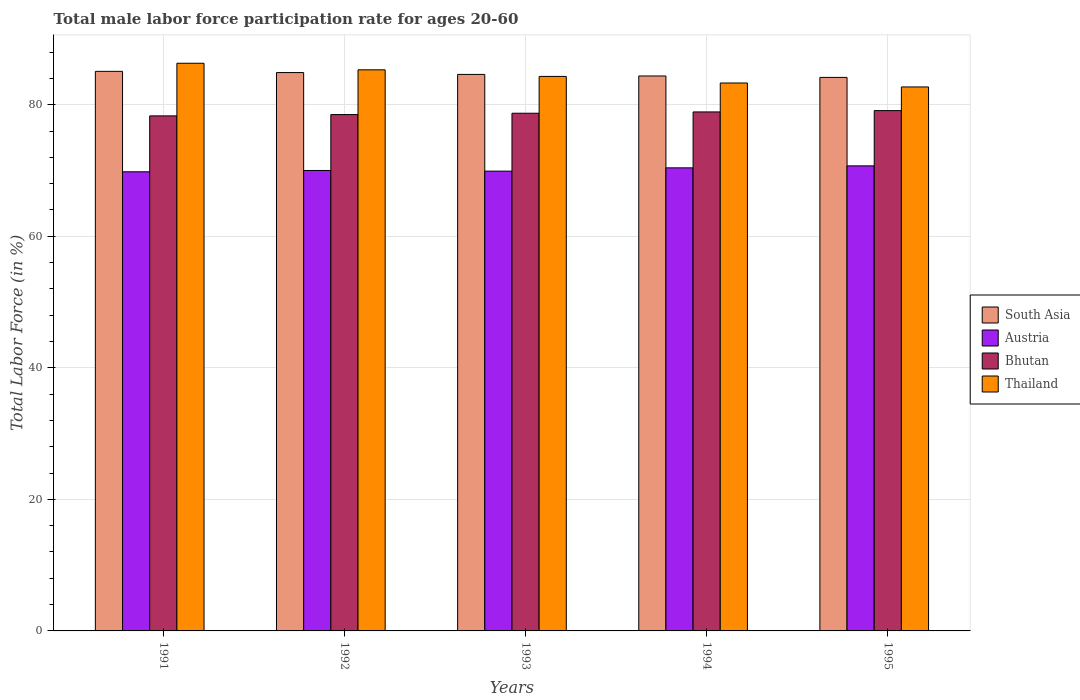How many different coloured bars are there?
Offer a terse response. 4. Are the number of bars per tick equal to the number of legend labels?
Provide a short and direct response. Yes. What is the label of the 4th group of bars from the left?
Keep it short and to the point. 1994. What is the male labor force participation rate in Thailand in 1992?
Provide a succinct answer. 85.3. Across all years, what is the maximum male labor force participation rate in Bhutan?
Offer a very short reply. 79.1. Across all years, what is the minimum male labor force participation rate in Austria?
Provide a succinct answer. 69.8. In which year was the male labor force participation rate in Thailand maximum?
Your answer should be very brief. 1991. In which year was the male labor force participation rate in South Asia minimum?
Your answer should be very brief. 1995. What is the total male labor force participation rate in South Asia in the graph?
Offer a terse response. 423.08. What is the difference between the male labor force participation rate in Bhutan in 1993 and that in 1994?
Your answer should be very brief. -0.2. What is the difference between the male labor force participation rate in Austria in 1991 and the male labor force participation rate in Thailand in 1994?
Your answer should be very brief. -13.5. What is the average male labor force participation rate in Thailand per year?
Your response must be concise. 84.38. In the year 1993, what is the difference between the male labor force participation rate in Thailand and male labor force participation rate in Bhutan?
Provide a succinct answer. 5.6. What is the ratio of the male labor force participation rate in South Asia in 1992 to that in 1995?
Provide a short and direct response. 1.01. Is the male labor force participation rate in South Asia in 1991 less than that in 1992?
Provide a succinct answer. No. Is the difference between the male labor force participation rate in Thailand in 1992 and 1993 greater than the difference between the male labor force participation rate in Bhutan in 1992 and 1993?
Your answer should be very brief. Yes. What is the difference between the highest and the second highest male labor force participation rate in South Asia?
Offer a very short reply. 0.19. What is the difference between the highest and the lowest male labor force participation rate in Thailand?
Offer a terse response. 3.6. In how many years, is the male labor force participation rate in Bhutan greater than the average male labor force participation rate in Bhutan taken over all years?
Ensure brevity in your answer.  2. What does the 4th bar from the left in 1991 represents?
Your response must be concise. Thailand. What does the 4th bar from the right in 1995 represents?
Give a very brief answer. South Asia. Is it the case that in every year, the sum of the male labor force participation rate in Bhutan and male labor force participation rate in Austria is greater than the male labor force participation rate in Thailand?
Keep it short and to the point. Yes. How many bars are there?
Provide a short and direct response. 20. How many years are there in the graph?
Give a very brief answer. 5. What is the difference between two consecutive major ticks on the Y-axis?
Ensure brevity in your answer.  20. Are the values on the major ticks of Y-axis written in scientific E-notation?
Provide a short and direct response. No. Does the graph contain grids?
Offer a very short reply. Yes. Where does the legend appear in the graph?
Your answer should be compact. Center right. How are the legend labels stacked?
Provide a short and direct response. Vertical. What is the title of the graph?
Offer a very short reply. Total male labor force participation rate for ages 20-60. What is the label or title of the Y-axis?
Your answer should be compact. Total Labor Force (in %). What is the Total Labor Force (in %) in South Asia in 1991?
Your response must be concise. 85.07. What is the Total Labor Force (in %) in Austria in 1991?
Ensure brevity in your answer.  69.8. What is the Total Labor Force (in %) in Bhutan in 1991?
Your answer should be compact. 78.3. What is the Total Labor Force (in %) of Thailand in 1991?
Provide a short and direct response. 86.3. What is the Total Labor Force (in %) of South Asia in 1992?
Make the answer very short. 84.88. What is the Total Labor Force (in %) in Austria in 1992?
Make the answer very short. 70. What is the Total Labor Force (in %) in Bhutan in 1992?
Your answer should be very brief. 78.5. What is the Total Labor Force (in %) in Thailand in 1992?
Your answer should be very brief. 85.3. What is the Total Labor Force (in %) in South Asia in 1993?
Offer a very short reply. 84.6. What is the Total Labor Force (in %) in Austria in 1993?
Provide a short and direct response. 69.9. What is the Total Labor Force (in %) in Bhutan in 1993?
Offer a very short reply. 78.7. What is the Total Labor Force (in %) of Thailand in 1993?
Offer a very short reply. 84.3. What is the Total Labor Force (in %) in South Asia in 1994?
Offer a very short reply. 84.37. What is the Total Labor Force (in %) of Austria in 1994?
Make the answer very short. 70.4. What is the Total Labor Force (in %) of Bhutan in 1994?
Your response must be concise. 78.9. What is the Total Labor Force (in %) in Thailand in 1994?
Offer a terse response. 83.3. What is the Total Labor Force (in %) of South Asia in 1995?
Your answer should be very brief. 84.15. What is the Total Labor Force (in %) in Austria in 1995?
Make the answer very short. 70.7. What is the Total Labor Force (in %) in Bhutan in 1995?
Provide a short and direct response. 79.1. What is the Total Labor Force (in %) of Thailand in 1995?
Your answer should be very brief. 82.7. Across all years, what is the maximum Total Labor Force (in %) in South Asia?
Make the answer very short. 85.07. Across all years, what is the maximum Total Labor Force (in %) of Austria?
Offer a terse response. 70.7. Across all years, what is the maximum Total Labor Force (in %) of Bhutan?
Make the answer very short. 79.1. Across all years, what is the maximum Total Labor Force (in %) in Thailand?
Keep it short and to the point. 86.3. Across all years, what is the minimum Total Labor Force (in %) of South Asia?
Provide a succinct answer. 84.15. Across all years, what is the minimum Total Labor Force (in %) of Austria?
Ensure brevity in your answer.  69.8. Across all years, what is the minimum Total Labor Force (in %) of Bhutan?
Keep it short and to the point. 78.3. Across all years, what is the minimum Total Labor Force (in %) in Thailand?
Give a very brief answer. 82.7. What is the total Total Labor Force (in %) in South Asia in the graph?
Offer a terse response. 423.08. What is the total Total Labor Force (in %) of Austria in the graph?
Make the answer very short. 350.8. What is the total Total Labor Force (in %) of Bhutan in the graph?
Your response must be concise. 393.5. What is the total Total Labor Force (in %) in Thailand in the graph?
Provide a succinct answer. 421.9. What is the difference between the Total Labor Force (in %) in South Asia in 1991 and that in 1992?
Give a very brief answer. 0.19. What is the difference between the Total Labor Force (in %) in South Asia in 1991 and that in 1993?
Ensure brevity in your answer.  0.47. What is the difference between the Total Labor Force (in %) of Austria in 1991 and that in 1993?
Provide a short and direct response. -0.1. What is the difference between the Total Labor Force (in %) in Bhutan in 1991 and that in 1993?
Provide a short and direct response. -0.4. What is the difference between the Total Labor Force (in %) of Thailand in 1991 and that in 1993?
Make the answer very short. 2. What is the difference between the Total Labor Force (in %) in South Asia in 1991 and that in 1994?
Your answer should be compact. 0.7. What is the difference between the Total Labor Force (in %) in Austria in 1991 and that in 1994?
Keep it short and to the point. -0.6. What is the difference between the Total Labor Force (in %) in Bhutan in 1991 and that in 1994?
Give a very brief answer. -0.6. What is the difference between the Total Labor Force (in %) of Thailand in 1991 and that in 1994?
Your answer should be compact. 3. What is the difference between the Total Labor Force (in %) of South Asia in 1991 and that in 1995?
Your answer should be very brief. 0.92. What is the difference between the Total Labor Force (in %) in Austria in 1991 and that in 1995?
Ensure brevity in your answer.  -0.9. What is the difference between the Total Labor Force (in %) of Thailand in 1991 and that in 1995?
Ensure brevity in your answer.  3.6. What is the difference between the Total Labor Force (in %) of South Asia in 1992 and that in 1993?
Offer a terse response. 0.28. What is the difference between the Total Labor Force (in %) of Austria in 1992 and that in 1993?
Give a very brief answer. 0.1. What is the difference between the Total Labor Force (in %) of Bhutan in 1992 and that in 1993?
Make the answer very short. -0.2. What is the difference between the Total Labor Force (in %) in South Asia in 1992 and that in 1994?
Provide a short and direct response. 0.52. What is the difference between the Total Labor Force (in %) of Bhutan in 1992 and that in 1994?
Offer a terse response. -0.4. What is the difference between the Total Labor Force (in %) in South Asia in 1992 and that in 1995?
Keep it short and to the point. 0.74. What is the difference between the Total Labor Force (in %) in Austria in 1992 and that in 1995?
Your answer should be compact. -0.7. What is the difference between the Total Labor Force (in %) in South Asia in 1993 and that in 1994?
Your answer should be compact. 0.24. What is the difference between the Total Labor Force (in %) in Bhutan in 1993 and that in 1994?
Your answer should be very brief. -0.2. What is the difference between the Total Labor Force (in %) in South Asia in 1993 and that in 1995?
Your answer should be very brief. 0.45. What is the difference between the Total Labor Force (in %) in Austria in 1993 and that in 1995?
Offer a terse response. -0.8. What is the difference between the Total Labor Force (in %) of South Asia in 1994 and that in 1995?
Provide a succinct answer. 0.22. What is the difference between the Total Labor Force (in %) in Austria in 1994 and that in 1995?
Offer a very short reply. -0.3. What is the difference between the Total Labor Force (in %) of Bhutan in 1994 and that in 1995?
Offer a terse response. -0.2. What is the difference between the Total Labor Force (in %) in Thailand in 1994 and that in 1995?
Your answer should be compact. 0.6. What is the difference between the Total Labor Force (in %) of South Asia in 1991 and the Total Labor Force (in %) of Austria in 1992?
Provide a succinct answer. 15.07. What is the difference between the Total Labor Force (in %) in South Asia in 1991 and the Total Labor Force (in %) in Bhutan in 1992?
Ensure brevity in your answer.  6.57. What is the difference between the Total Labor Force (in %) in South Asia in 1991 and the Total Labor Force (in %) in Thailand in 1992?
Keep it short and to the point. -0.23. What is the difference between the Total Labor Force (in %) of Austria in 1991 and the Total Labor Force (in %) of Thailand in 1992?
Keep it short and to the point. -15.5. What is the difference between the Total Labor Force (in %) in South Asia in 1991 and the Total Labor Force (in %) in Austria in 1993?
Keep it short and to the point. 15.17. What is the difference between the Total Labor Force (in %) of South Asia in 1991 and the Total Labor Force (in %) of Bhutan in 1993?
Provide a short and direct response. 6.37. What is the difference between the Total Labor Force (in %) in South Asia in 1991 and the Total Labor Force (in %) in Thailand in 1993?
Provide a succinct answer. 0.77. What is the difference between the Total Labor Force (in %) in Austria in 1991 and the Total Labor Force (in %) in Thailand in 1993?
Make the answer very short. -14.5. What is the difference between the Total Labor Force (in %) in South Asia in 1991 and the Total Labor Force (in %) in Austria in 1994?
Your answer should be very brief. 14.67. What is the difference between the Total Labor Force (in %) of South Asia in 1991 and the Total Labor Force (in %) of Bhutan in 1994?
Keep it short and to the point. 6.17. What is the difference between the Total Labor Force (in %) of South Asia in 1991 and the Total Labor Force (in %) of Thailand in 1994?
Provide a short and direct response. 1.77. What is the difference between the Total Labor Force (in %) in South Asia in 1991 and the Total Labor Force (in %) in Austria in 1995?
Offer a very short reply. 14.37. What is the difference between the Total Labor Force (in %) in South Asia in 1991 and the Total Labor Force (in %) in Bhutan in 1995?
Make the answer very short. 5.97. What is the difference between the Total Labor Force (in %) of South Asia in 1991 and the Total Labor Force (in %) of Thailand in 1995?
Keep it short and to the point. 2.37. What is the difference between the Total Labor Force (in %) of Bhutan in 1991 and the Total Labor Force (in %) of Thailand in 1995?
Your answer should be compact. -4.4. What is the difference between the Total Labor Force (in %) of South Asia in 1992 and the Total Labor Force (in %) of Austria in 1993?
Your response must be concise. 14.98. What is the difference between the Total Labor Force (in %) in South Asia in 1992 and the Total Labor Force (in %) in Bhutan in 1993?
Your response must be concise. 6.18. What is the difference between the Total Labor Force (in %) of South Asia in 1992 and the Total Labor Force (in %) of Thailand in 1993?
Make the answer very short. 0.58. What is the difference between the Total Labor Force (in %) in Austria in 1992 and the Total Labor Force (in %) in Bhutan in 1993?
Keep it short and to the point. -8.7. What is the difference between the Total Labor Force (in %) in Austria in 1992 and the Total Labor Force (in %) in Thailand in 1993?
Your answer should be compact. -14.3. What is the difference between the Total Labor Force (in %) in South Asia in 1992 and the Total Labor Force (in %) in Austria in 1994?
Keep it short and to the point. 14.48. What is the difference between the Total Labor Force (in %) in South Asia in 1992 and the Total Labor Force (in %) in Bhutan in 1994?
Make the answer very short. 5.98. What is the difference between the Total Labor Force (in %) of South Asia in 1992 and the Total Labor Force (in %) of Thailand in 1994?
Ensure brevity in your answer.  1.58. What is the difference between the Total Labor Force (in %) of South Asia in 1992 and the Total Labor Force (in %) of Austria in 1995?
Your response must be concise. 14.18. What is the difference between the Total Labor Force (in %) in South Asia in 1992 and the Total Labor Force (in %) in Bhutan in 1995?
Keep it short and to the point. 5.78. What is the difference between the Total Labor Force (in %) in South Asia in 1992 and the Total Labor Force (in %) in Thailand in 1995?
Make the answer very short. 2.18. What is the difference between the Total Labor Force (in %) of Austria in 1992 and the Total Labor Force (in %) of Thailand in 1995?
Provide a succinct answer. -12.7. What is the difference between the Total Labor Force (in %) of Bhutan in 1992 and the Total Labor Force (in %) of Thailand in 1995?
Offer a terse response. -4.2. What is the difference between the Total Labor Force (in %) in South Asia in 1993 and the Total Labor Force (in %) in Austria in 1994?
Make the answer very short. 14.2. What is the difference between the Total Labor Force (in %) in South Asia in 1993 and the Total Labor Force (in %) in Bhutan in 1994?
Offer a very short reply. 5.7. What is the difference between the Total Labor Force (in %) in South Asia in 1993 and the Total Labor Force (in %) in Thailand in 1994?
Give a very brief answer. 1.3. What is the difference between the Total Labor Force (in %) of South Asia in 1993 and the Total Labor Force (in %) of Austria in 1995?
Your answer should be compact. 13.9. What is the difference between the Total Labor Force (in %) in South Asia in 1993 and the Total Labor Force (in %) in Bhutan in 1995?
Offer a terse response. 5.5. What is the difference between the Total Labor Force (in %) of South Asia in 1993 and the Total Labor Force (in %) of Thailand in 1995?
Ensure brevity in your answer.  1.9. What is the difference between the Total Labor Force (in %) of Austria in 1993 and the Total Labor Force (in %) of Thailand in 1995?
Make the answer very short. -12.8. What is the difference between the Total Labor Force (in %) of South Asia in 1994 and the Total Labor Force (in %) of Austria in 1995?
Provide a succinct answer. 13.67. What is the difference between the Total Labor Force (in %) of South Asia in 1994 and the Total Labor Force (in %) of Bhutan in 1995?
Keep it short and to the point. 5.27. What is the difference between the Total Labor Force (in %) of South Asia in 1994 and the Total Labor Force (in %) of Thailand in 1995?
Give a very brief answer. 1.67. What is the average Total Labor Force (in %) in South Asia per year?
Offer a terse response. 84.62. What is the average Total Labor Force (in %) in Austria per year?
Offer a terse response. 70.16. What is the average Total Labor Force (in %) of Bhutan per year?
Your answer should be very brief. 78.7. What is the average Total Labor Force (in %) in Thailand per year?
Provide a succinct answer. 84.38. In the year 1991, what is the difference between the Total Labor Force (in %) in South Asia and Total Labor Force (in %) in Austria?
Offer a very short reply. 15.27. In the year 1991, what is the difference between the Total Labor Force (in %) of South Asia and Total Labor Force (in %) of Bhutan?
Your answer should be very brief. 6.77. In the year 1991, what is the difference between the Total Labor Force (in %) in South Asia and Total Labor Force (in %) in Thailand?
Provide a short and direct response. -1.23. In the year 1991, what is the difference between the Total Labor Force (in %) of Austria and Total Labor Force (in %) of Bhutan?
Make the answer very short. -8.5. In the year 1991, what is the difference between the Total Labor Force (in %) of Austria and Total Labor Force (in %) of Thailand?
Provide a short and direct response. -16.5. In the year 1991, what is the difference between the Total Labor Force (in %) of Bhutan and Total Labor Force (in %) of Thailand?
Your response must be concise. -8. In the year 1992, what is the difference between the Total Labor Force (in %) of South Asia and Total Labor Force (in %) of Austria?
Give a very brief answer. 14.88. In the year 1992, what is the difference between the Total Labor Force (in %) in South Asia and Total Labor Force (in %) in Bhutan?
Offer a very short reply. 6.38. In the year 1992, what is the difference between the Total Labor Force (in %) of South Asia and Total Labor Force (in %) of Thailand?
Make the answer very short. -0.42. In the year 1992, what is the difference between the Total Labor Force (in %) of Austria and Total Labor Force (in %) of Thailand?
Your answer should be very brief. -15.3. In the year 1993, what is the difference between the Total Labor Force (in %) in South Asia and Total Labor Force (in %) in Austria?
Provide a succinct answer. 14.7. In the year 1993, what is the difference between the Total Labor Force (in %) of South Asia and Total Labor Force (in %) of Bhutan?
Make the answer very short. 5.9. In the year 1993, what is the difference between the Total Labor Force (in %) of South Asia and Total Labor Force (in %) of Thailand?
Offer a terse response. 0.3. In the year 1993, what is the difference between the Total Labor Force (in %) of Austria and Total Labor Force (in %) of Bhutan?
Keep it short and to the point. -8.8. In the year 1993, what is the difference between the Total Labor Force (in %) in Austria and Total Labor Force (in %) in Thailand?
Provide a succinct answer. -14.4. In the year 1994, what is the difference between the Total Labor Force (in %) in South Asia and Total Labor Force (in %) in Austria?
Keep it short and to the point. 13.97. In the year 1994, what is the difference between the Total Labor Force (in %) of South Asia and Total Labor Force (in %) of Bhutan?
Offer a terse response. 5.47. In the year 1994, what is the difference between the Total Labor Force (in %) in South Asia and Total Labor Force (in %) in Thailand?
Provide a succinct answer. 1.07. In the year 1994, what is the difference between the Total Labor Force (in %) of Austria and Total Labor Force (in %) of Bhutan?
Your answer should be compact. -8.5. In the year 1994, what is the difference between the Total Labor Force (in %) in Austria and Total Labor Force (in %) in Thailand?
Give a very brief answer. -12.9. In the year 1994, what is the difference between the Total Labor Force (in %) in Bhutan and Total Labor Force (in %) in Thailand?
Your answer should be compact. -4.4. In the year 1995, what is the difference between the Total Labor Force (in %) in South Asia and Total Labor Force (in %) in Austria?
Your answer should be very brief. 13.45. In the year 1995, what is the difference between the Total Labor Force (in %) in South Asia and Total Labor Force (in %) in Bhutan?
Your answer should be compact. 5.05. In the year 1995, what is the difference between the Total Labor Force (in %) of South Asia and Total Labor Force (in %) of Thailand?
Your response must be concise. 1.45. In the year 1995, what is the difference between the Total Labor Force (in %) in Austria and Total Labor Force (in %) in Bhutan?
Your answer should be compact. -8.4. In the year 1995, what is the difference between the Total Labor Force (in %) in Austria and Total Labor Force (in %) in Thailand?
Your answer should be compact. -12. In the year 1995, what is the difference between the Total Labor Force (in %) in Bhutan and Total Labor Force (in %) in Thailand?
Your answer should be very brief. -3.6. What is the ratio of the Total Labor Force (in %) of Thailand in 1991 to that in 1992?
Keep it short and to the point. 1.01. What is the ratio of the Total Labor Force (in %) of Bhutan in 1991 to that in 1993?
Offer a terse response. 0.99. What is the ratio of the Total Labor Force (in %) of Thailand in 1991 to that in 1993?
Give a very brief answer. 1.02. What is the ratio of the Total Labor Force (in %) in South Asia in 1991 to that in 1994?
Offer a terse response. 1.01. What is the ratio of the Total Labor Force (in %) of Austria in 1991 to that in 1994?
Your answer should be compact. 0.99. What is the ratio of the Total Labor Force (in %) of Bhutan in 1991 to that in 1994?
Provide a short and direct response. 0.99. What is the ratio of the Total Labor Force (in %) of Thailand in 1991 to that in 1994?
Keep it short and to the point. 1.04. What is the ratio of the Total Labor Force (in %) in South Asia in 1991 to that in 1995?
Your response must be concise. 1.01. What is the ratio of the Total Labor Force (in %) in Austria in 1991 to that in 1995?
Your answer should be compact. 0.99. What is the ratio of the Total Labor Force (in %) in Bhutan in 1991 to that in 1995?
Provide a short and direct response. 0.99. What is the ratio of the Total Labor Force (in %) in Thailand in 1991 to that in 1995?
Offer a very short reply. 1.04. What is the ratio of the Total Labor Force (in %) of Thailand in 1992 to that in 1993?
Provide a short and direct response. 1.01. What is the ratio of the Total Labor Force (in %) of South Asia in 1992 to that in 1994?
Provide a succinct answer. 1.01. What is the ratio of the Total Labor Force (in %) of Austria in 1992 to that in 1994?
Ensure brevity in your answer.  0.99. What is the ratio of the Total Labor Force (in %) in Bhutan in 1992 to that in 1994?
Give a very brief answer. 0.99. What is the ratio of the Total Labor Force (in %) in Thailand in 1992 to that in 1994?
Provide a short and direct response. 1.02. What is the ratio of the Total Labor Force (in %) of South Asia in 1992 to that in 1995?
Ensure brevity in your answer.  1.01. What is the ratio of the Total Labor Force (in %) in Bhutan in 1992 to that in 1995?
Give a very brief answer. 0.99. What is the ratio of the Total Labor Force (in %) in Thailand in 1992 to that in 1995?
Make the answer very short. 1.03. What is the ratio of the Total Labor Force (in %) of South Asia in 1993 to that in 1994?
Give a very brief answer. 1. What is the ratio of the Total Labor Force (in %) in South Asia in 1993 to that in 1995?
Your answer should be very brief. 1.01. What is the ratio of the Total Labor Force (in %) in Austria in 1993 to that in 1995?
Make the answer very short. 0.99. What is the ratio of the Total Labor Force (in %) of Bhutan in 1993 to that in 1995?
Ensure brevity in your answer.  0.99. What is the ratio of the Total Labor Force (in %) in Thailand in 1993 to that in 1995?
Provide a succinct answer. 1.02. What is the ratio of the Total Labor Force (in %) of South Asia in 1994 to that in 1995?
Ensure brevity in your answer.  1. What is the ratio of the Total Labor Force (in %) of Thailand in 1994 to that in 1995?
Provide a short and direct response. 1.01. What is the difference between the highest and the second highest Total Labor Force (in %) in South Asia?
Provide a succinct answer. 0.19. What is the difference between the highest and the second highest Total Labor Force (in %) in Bhutan?
Ensure brevity in your answer.  0.2. What is the difference between the highest and the lowest Total Labor Force (in %) of South Asia?
Give a very brief answer. 0.92. What is the difference between the highest and the lowest Total Labor Force (in %) in Austria?
Give a very brief answer. 0.9. What is the difference between the highest and the lowest Total Labor Force (in %) of Thailand?
Your response must be concise. 3.6. 